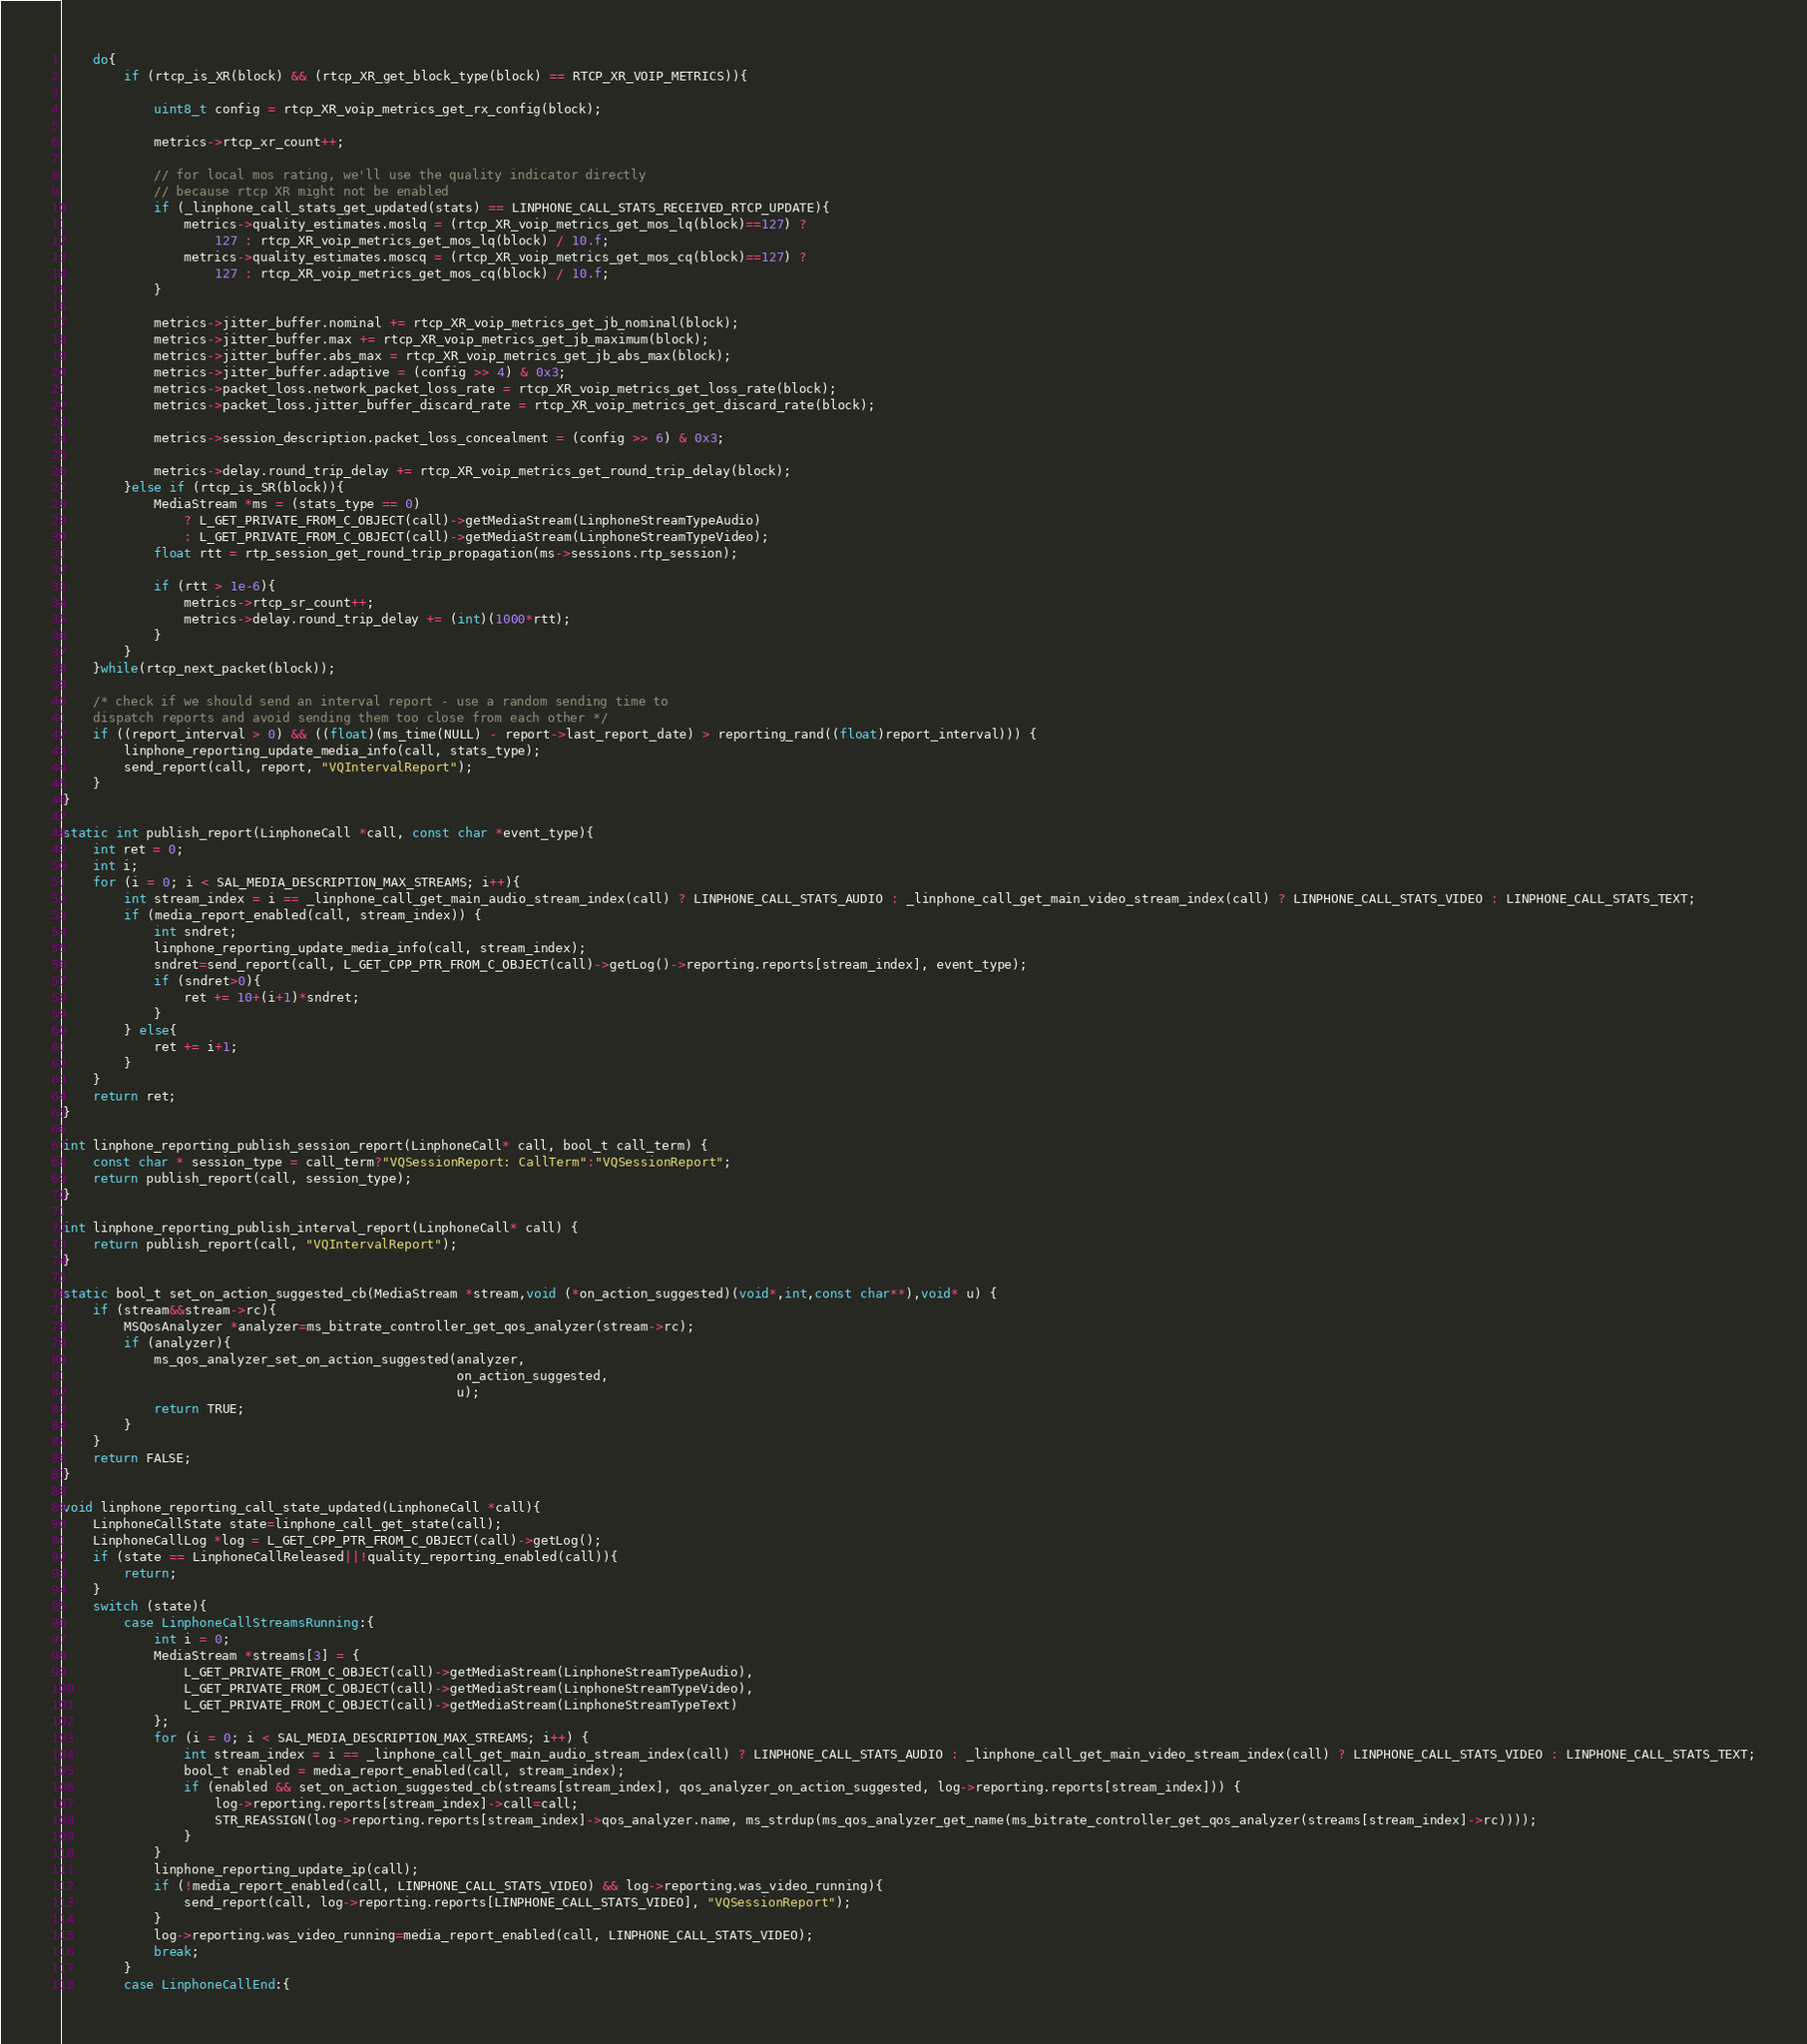<code> <loc_0><loc_0><loc_500><loc_500><_C_>	do{
		if (rtcp_is_XR(block) && (rtcp_XR_get_block_type(block) == RTCP_XR_VOIP_METRICS)){

			uint8_t config = rtcp_XR_voip_metrics_get_rx_config(block);

			metrics->rtcp_xr_count++;

			// for local mos rating, we'll use the quality indicator directly
			// because rtcp XR might not be enabled
			if (_linphone_call_stats_get_updated(stats) == LINPHONE_CALL_STATS_RECEIVED_RTCP_UPDATE){
				metrics->quality_estimates.moslq = (rtcp_XR_voip_metrics_get_mos_lq(block)==127) ?
					127 : rtcp_XR_voip_metrics_get_mos_lq(block) / 10.f;
				metrics->quality_estimates.moscq = (rtcp_XR_voip_metrics_get_mos_cq(block)==127) ?
					127 : rtcp_XR_voip_metrics_get_mos_cq(block) / 10.f;
			}

			metrics->jitter_buffer.nominal += rtcp_XR_voip_metrics_get_jb_nominal(block);
			metrics->jitter_buffer.max += rtcp_XR_voip_metrics_get_jb_maximum(block);
			metrics->jitter_buffer.abs_max = rtcp_XR_voip_metrics_get_jb_abs_max(block);
			metrics->jitter_buffer.adaptive = (config >> 4) & 0x3;
			metrics->packet_loss.network_packet_loss_rate = rtcp_XR_voip_metrics_get_loss_rate(block);
			metrics->packet_loss.jitter_buffer_discard_rate = rtcp_XR_voip_metrics_get_discard_rate(block);

			metrics->session_description.packet_loss_concealment = (config >> 6) & 0x3;

			metrics->delay.round_trip_delay += rtcp_XR_voip_metrics_get_round_trip_delay(block);
		}else if (rtcp_is_SR(block)){
			MediaStream *ms = (stats_type == 0)
				? L_GET_PRIVATE_FROM_C_OBJECT(call)->getMediaStream(LinphoneStreamTypeAudio)
				: L_GET_PRIVATE_FROM_C_OBJECT(call)->getMediaStream(LinphoneStreamTypeVideo);
			float rtt = rtp_session_get_round_trip_propagation(ms->sessions.rtp_session);

			if (rtt > 1e-6){
				metrics->rtcp_sr_count++;
				metrics->delay.round_trip_delay += (int)(1000*rtt);
			}
		}
	}while(rtcp_next_packet(block));

	/* check if we should send an interval report - use a random sending time to
	dispatch reports and avoid sending them too close from each other */
	if ((report_interval > 0) && ((float)(ms_time(NULL) - report->last_report_date) > reporting_rand((float)report_interval))) {
		linphone_reporting_update_media_info(call, stats_type);
		send_report(call, report, "VQIntervalReport");
	}
}

static int publish_report(LinphoneCall *call, const char *event_type){
	int ret = 0;
	int i;
	for (i = 0; i < SAL_MEDIA_DESCRIPTION_MAX_STREAMS; i++){
		int stream_index = i == _linphone_call_get_main_audio_stream_index(call) ? LINPHONE_CALL_STATS_AUDIO : _linphone_call_get_main_video_stream_index(call) ? LINPHONE_CALL_STATS_VIDEO : LINPHONE_CALL_STATS_TEXT;
		if (media_report_enabled(call, stream_index)) {
			int sndret;
			linphone_reporting_update_media_info(call, stream_index);
			sndret=send_report(call, L_GET_CPP_PTR_FROM_C_OBJECT(call)->getLog()->reporting.reports[stream_index], event_type);
			if (sndret>0){
				ret += 10+(i+1)*sndret;
			}
		} else{
			ret += i+1;
		}
	}
	return ret;
}

int linphone_reporting_publish_session_report(LinphoneCall* call, bool_t call_term) {
	const char * session_type = call_term?"VQSessionReport: CallTerm":"VQSessionReport";
	return publish_report(call, session_type);
}

int linphone_reporting_publish_interval_report(LinphoneCall* call) {
	return publish_report(call, "VQIntervalReport");
}

static bool_t set_on_action_suggested_cb(MediaStream *stream,void (*on_action_suggested)(void*,int,const char**),void* u) {
	if (stream&&stream->rc){
		MSQosAnalyzer *analyzer=ms_bitrate_controller_get_qos_analyzer(stream->rc);
		if (analyzer){
			ms_qos_analyzer_set_on_action_suggested(analyzer,
													on_action_suggested,
													u);
			return TRUE;
		}
	}
	return FALSE;
}

void linphone_reporting_call_state_updated(LinphoneCall *call){
	LinphoneCallState state=linphone_call_get_state(call);
	LinphoneCallLog *log = L_GET_CPP_PTR_FROM_C_OBJECT(call)->getLog();
	if (state == LinphoneCallReleased||!quality_reporting_enabled(call)){
		return;
	}
	switch (state){
		case LinphoneCallStreamsRunning:{
			int i = 0;
			MediaStream *streams[3] = {
				L_GET_PRIVATE_FROM_C_OBJECT(call)->getMediaStream(LinphoneStreamTypeAudio),
				L_GET_PRIVATE_FROM_C_OBJECT(call)->getMediaStream(LinphoneStreamTypeVideo),
				L_GET_PRIVATE_FROM_C_OBJECT(call)->getMediaStream(LinphoneStreamTypeText)
			};
			for (i = 0; i < SAL_MEDIA_DESCRIPTION_MAX_STREAMS; i++) {
				int stream_index = i == _linphone_call_get_main_audio_stream_index(call) ? LINPHONE_CALL_STATS_AUDIO : _linphone_call_get_main_video_stream_index(call) ? LINPHONE_CALL_STATS_VIDEO : LINPHONE_CALL_STATS_TEXT;
				bool_t enabled = media_report_enabled(call, stream_index);
				if (enabled && set_on_action_suggested_cb(streams[stream_index], qos_analyzer_on_action_suggested, log->reporting.reports[stream_index])) {
					log->reporting.reports[stream_index]->call=call;
					STR_REASSIGN(log->reporting.reports[stream_index]->qos_analyzer.name, ms_strdup(ms_qos_analyzer_get_name(ms_bitrate_controller_get_qos_analyzer(streams[stream_index]->rc))));
				}
			}
			linphone_reporting_update_ip(call);
			if (!media_report_enabled(call, LINPHONE_CALL_STATS_VIDEO) && log->reporting.was_video_running){
				send_report(call, log->reporting.reports[LINPHONE_CALL_STATS_VIDEO], "VQSessionReport");
			}
			log->reporting.was_video_running=media_report_enabled(call, LINPHONE_CALL_STATS_VIDEO);
			break;
		}
		case LinphoneCallEnd:{</code> 